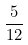Convert formula to latex. <formula><loc_0><loc_0><loc_500><loc_500>\frac { 5 } { 1 2 }</formula> 